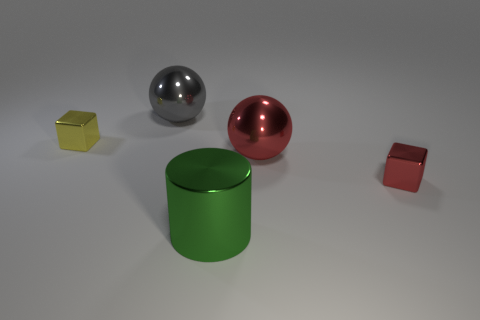Is the number of cubes behind the small red thing less than the number of tiny red metal blocks?
Make the answer very short. No. There is a big thing that is behind the tiny red thing and on the right side of the gray object; what color is it?
Offer a terse response. Red. What number of other objects are the same shape as the green metal thing?
Provide a short and direct response. 0. Are there fewer spheres on the left side of the large green metal cylinder than things right of the yellow shiny cube?
Offer a very short reply. Yes. Are there more green metallic cylinders than small purple metal balls?
Offer a terse response. Yes. There is a small thing to the right of the shiny cube that is behind the block that is to the right of the big green cylinder; what shape is it?
Provide a succinct answer. Cube. Do the gray thing on the left side of the red shiny sphere and the tiny cube on the left side of the metallic cylinder have the same material?
Provide a short and direct response. Yes. What is the shape of the gray thing that is made of the same material as the tiny yellow block?
Give a very brief answer. Sphere. Are there any other things of the same color as the metallic cylinder?
Ensure brevity in your answer.  No. What number of shiny spheres are there?
Offer a very short reply. 2. 